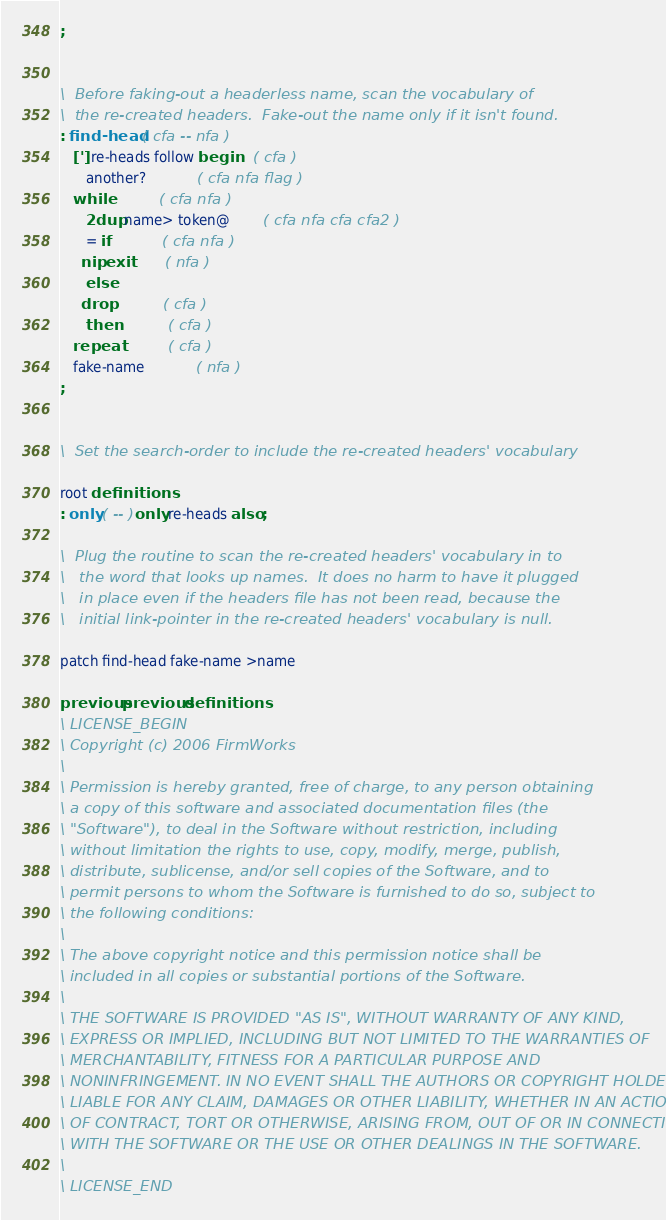Convert code to text. <code><loc_0><loc_0><loc_500><loc_500><_Forth_>;


\  Before faking-out a headerless name, scan the vocabulary of
\  the re-created headers.  Fake-out the name only if it isn't found.
: find-head  ( cfa -- nfa )
   ['] re-heads follow begin	( cfa )
      another?			( cfa nfa flag )
   while			( cfa nfa )
      2dup name> token@		( cfa nfa cfa cfa2 )
      = if			( cfa nfa )
	 nip exit		( nfa )
      else
	 drop			( cfa )
      then			( cfa )
   repeat			( cfa )
   fake-name			( nfa )
;


\  Set the search-order to include the re-created headers' vocabulary

root definitions
: only ( -- ) only re-heads also ;

\  Plug the routine to scan the re-created headers' vocabulary in to
\	the word that looks up names.  It does no harm to have it plugged
\	in place even if the headers file has not been read, because the
\	initial link-pointer in the re-created headers' vocabulary is null.

patch find-head fake-name >name

previous previous definitions
\ LICENSE_BEGIN
\ Copyright (c) 2006 FirmWorks
\ 
\ Permission is hereby granted, free of charge, to any person obtaining
\ a copy of this software and associated documentation files (the
\ "Software"), to deal in the Software without restriction, including
\ without limitation the rights to use, copy, modify, merge, publish,
\ distribute, sublicense, and/or sell copies of the Software, and to
\ permit persons to whom the Software is furnished to do so, subject to
\ the following conditions:
\ 
\ The above copyright notice and this permission notice shall be
\ included in all copies or substantial portions of the Software.
\ 
\ THE SOFTWARE IS PROVIDED "AS IS", WITHOUT WARRANTY OF ANY KIND,
\ EXPRESS OR IMPLIED, INCLUDING BUT NOT LIMITED TO THE WARRANTIES OF
\ MERCHANTABILITY, FITNESS FOR A PARTICULAR PURPOSE AND
\ NONINFRINGEMENT. IN NO EVENT SHALL THE AUTHORS OR COPYRIGHT HOLDERS BE
\ LIABLE FOR ANY CLAIM, DAMAGES OR OTHER LIABILITY, WHETHER IN AN ACTION
\ OF CONTRACT, TORT OR OTHERWISE, ARISING FROM, OUT OF OR IN CONNECTION
\ WITH THE SOFTWARE OR THE USE OR OTHER DEALINGS IN THE SOFTWARE.
\
\ LICENSE_END
</code> 